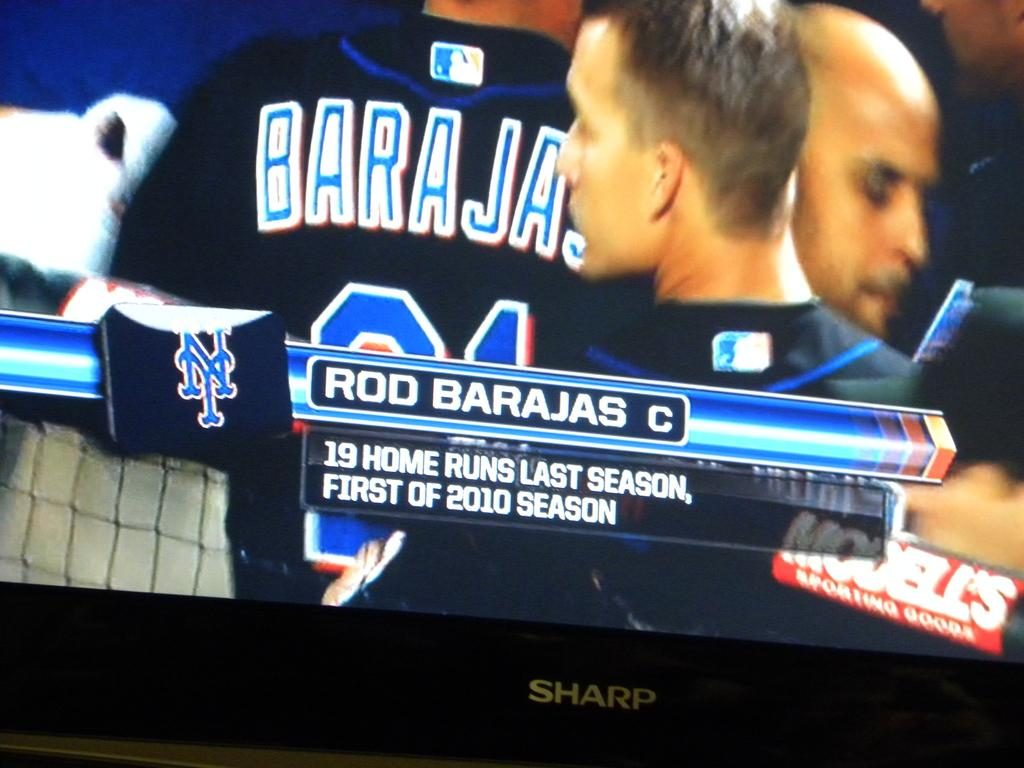Provide a one-sentence caption for the provided image. Rod Barajas' season home run statistic is captured on the Sharp television. 